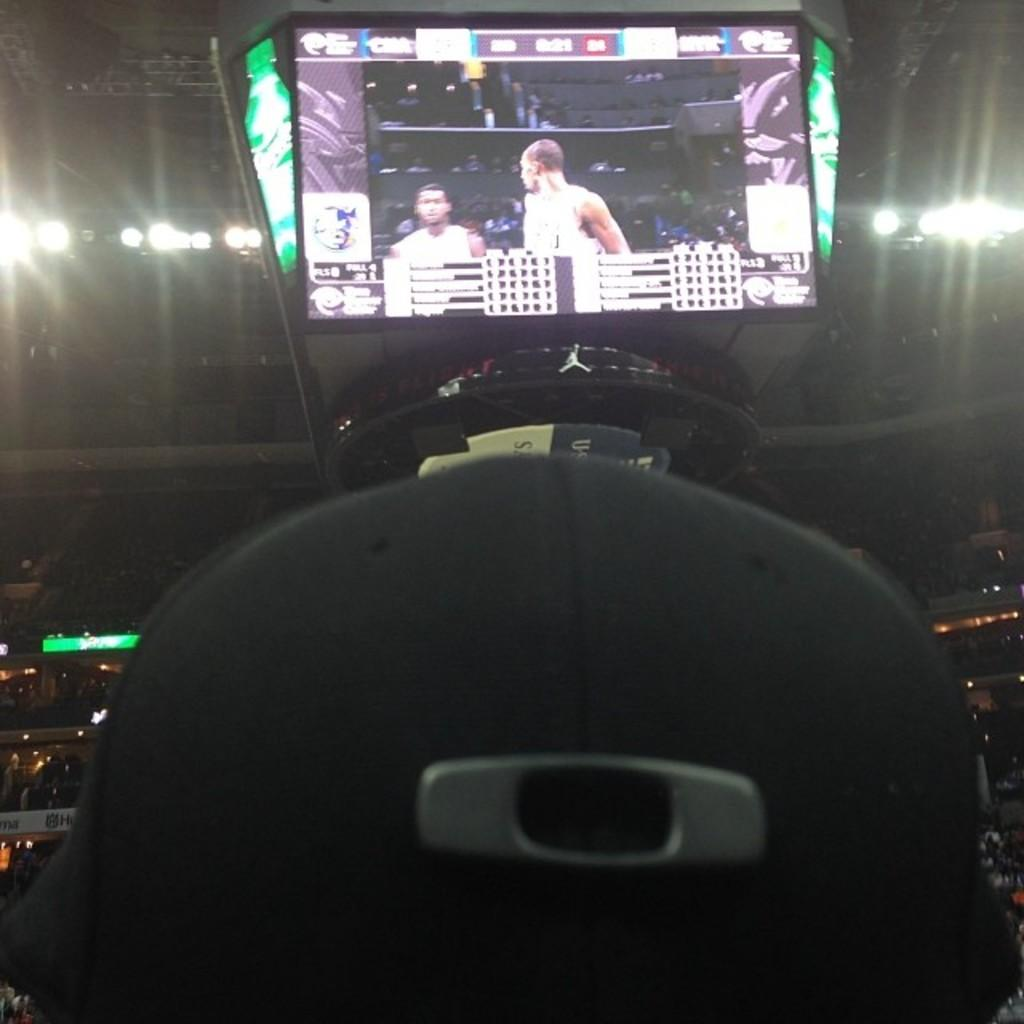What can be seen on the screens in the image? The facts do not specify what is on the screens, so we cannot answer that question definitively. What type of lights are present in the image? The facts do not specify the type of lights, so we cannot answer that question definitively. Can you describe the unspecified objects in the image? The facts do not specify the nature of the unspecified objects, so we cannot answer that question definitively. How many cabbages are being held by the person in the image? There is no person present in the image, and therefore no one is holding any cabbages. What type of fang can be seen in the image? There is no fang present in the image. 